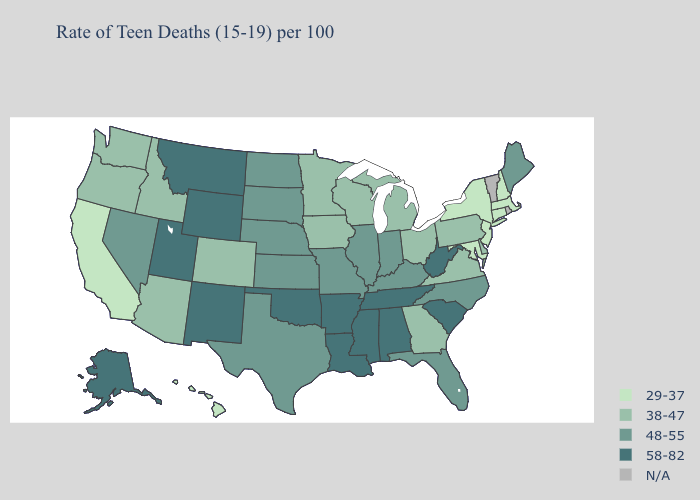What is the value of Illinois?
Concise answer only. 48-55. Does Maryland have the lowest value in the South?
Give a very brief answer. Yes. What is the highest value in states that border Kansas?
Be succinct. 58-82. What is the highest value in the South ?
Be succinct. 58-82. Which states have the highest value in the USA?
Write a very short answer. Alabama, Alaska, Arkansas, Louisiana, Mississippi, Montana, New Mexico, Oklahoma, South Carolina, Tennessee, Utah, West Virginia, Wyoming. Does the map have missing data?
Quick response, please. Yes. Name the states that have a value in the range 58-82?
Write a very short answer. Alabama, Alaska, Arkansas, Louisiana, Mississippi, Montana, New Mexico, Oklahoma, South Carolina, Tennessee, Utah, West Virginia, Wyoming. What is the lowest value in states that border Rhode Island?
Quick response, please. 29-37. Which states have the lowest value in the South?
Be succinct. Maryland. How many symbols are there in the legend?
Write a very short answer. 5. Which states have the lowest value in the USA?
Answer briefly. California, Connecticut, Hawaii, Maryland, Massachusetts, New Hampshire, New Jersey, New York. Does New York have the lowest value in the USA?
Answer briefly. Yes. Which states have the highest value in the USA?
Quick response, please. Alabama, Alaska, Arkansas, Louisiana, Mississippi, Montana, New Mexico, Oklahoma, South Carolina, Tennessee, Utah, West Virginia, Wyoming. 